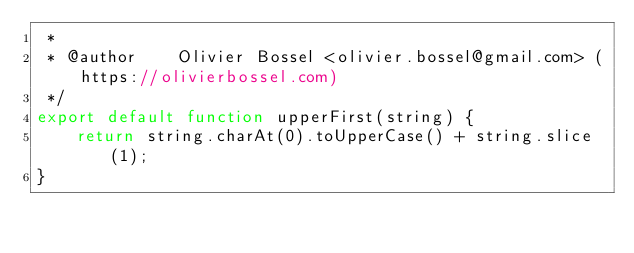<code> <loc_0><loc_0><loc_500><loc_500><_JavaScript_> *
 * @author    Olivier Bossel <olivier.bossel@gmail.com> (https://olivierbossel.com)
 */
export default function upperFirst(string) {
	return string.charAt(0).toUpperCase() + string.slice(1);
}
</code> 